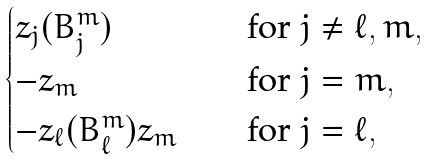Convert formula to latex. <formula><loc_0><loc_0><loc_500><loc_500>\begin{cases} z _ { j } ( B ^ { m } _ { j } ) \quad & \text {for $j\neq \ell, m$} , \\ - z _ { m } \quad & \text {for $j=m$} , \\ - z _ { \ell } ( B ^ { m } _ { \ell } ) z _ { m } \quad & \text {for $j=\ell$} , \\ \end{cases}</formula> 